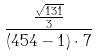Convert formula to latex. <formula><loc_0><loc_0><loc_500><loc_500>\frac { \frac { \sqrt { 1 3 1 } } { 3 } } { ( 4 5 4 - 1 ) \cdot 7 }</formula> 